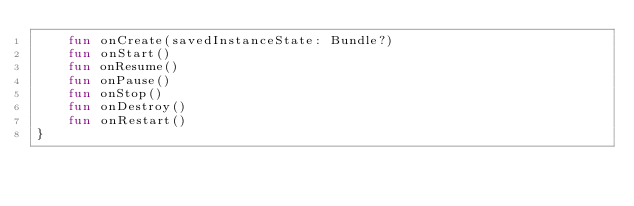Convert code to text. <code><loc_0><loc_0><loc_500><loc_500><_Kotlin_>    fun onCreate(savedInstanceState: Bundle?)
    fun onStart()
    fun onResume()
    fun onPause()
    fun onStop()
    fun onDestroy()
    fun onRestart()
}</code> 